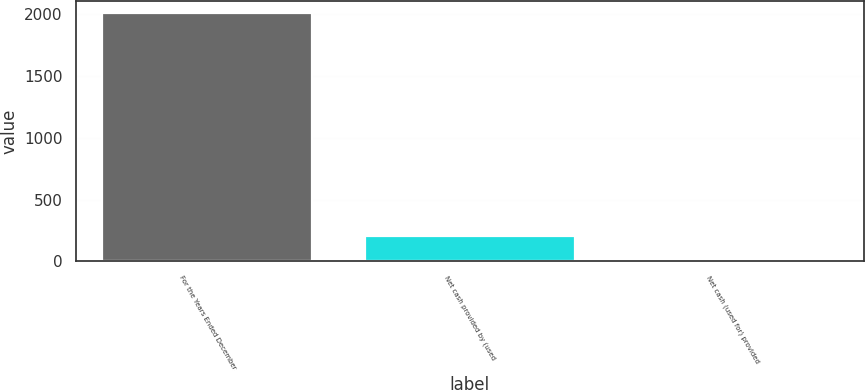Convert chart to OTSL. <chart><loc_0><loc_0><loc_500><loc_500><bar_chart><fcel>For the Years Ended December<fcel>Net cash provided by (used<fcel>Net cash (used for) provided<nl><fcel>2007<fcel>207.9<fcel>8<nl></chart> 